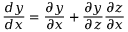<formula> <loc_0><loc_0><loc_500><loc_500>\frac { d y } { d x } = \frac { \partial y } { \partial x } + \frac { \partial y } { \partial z } \frac { \partial z } { \partial x }</formula> 